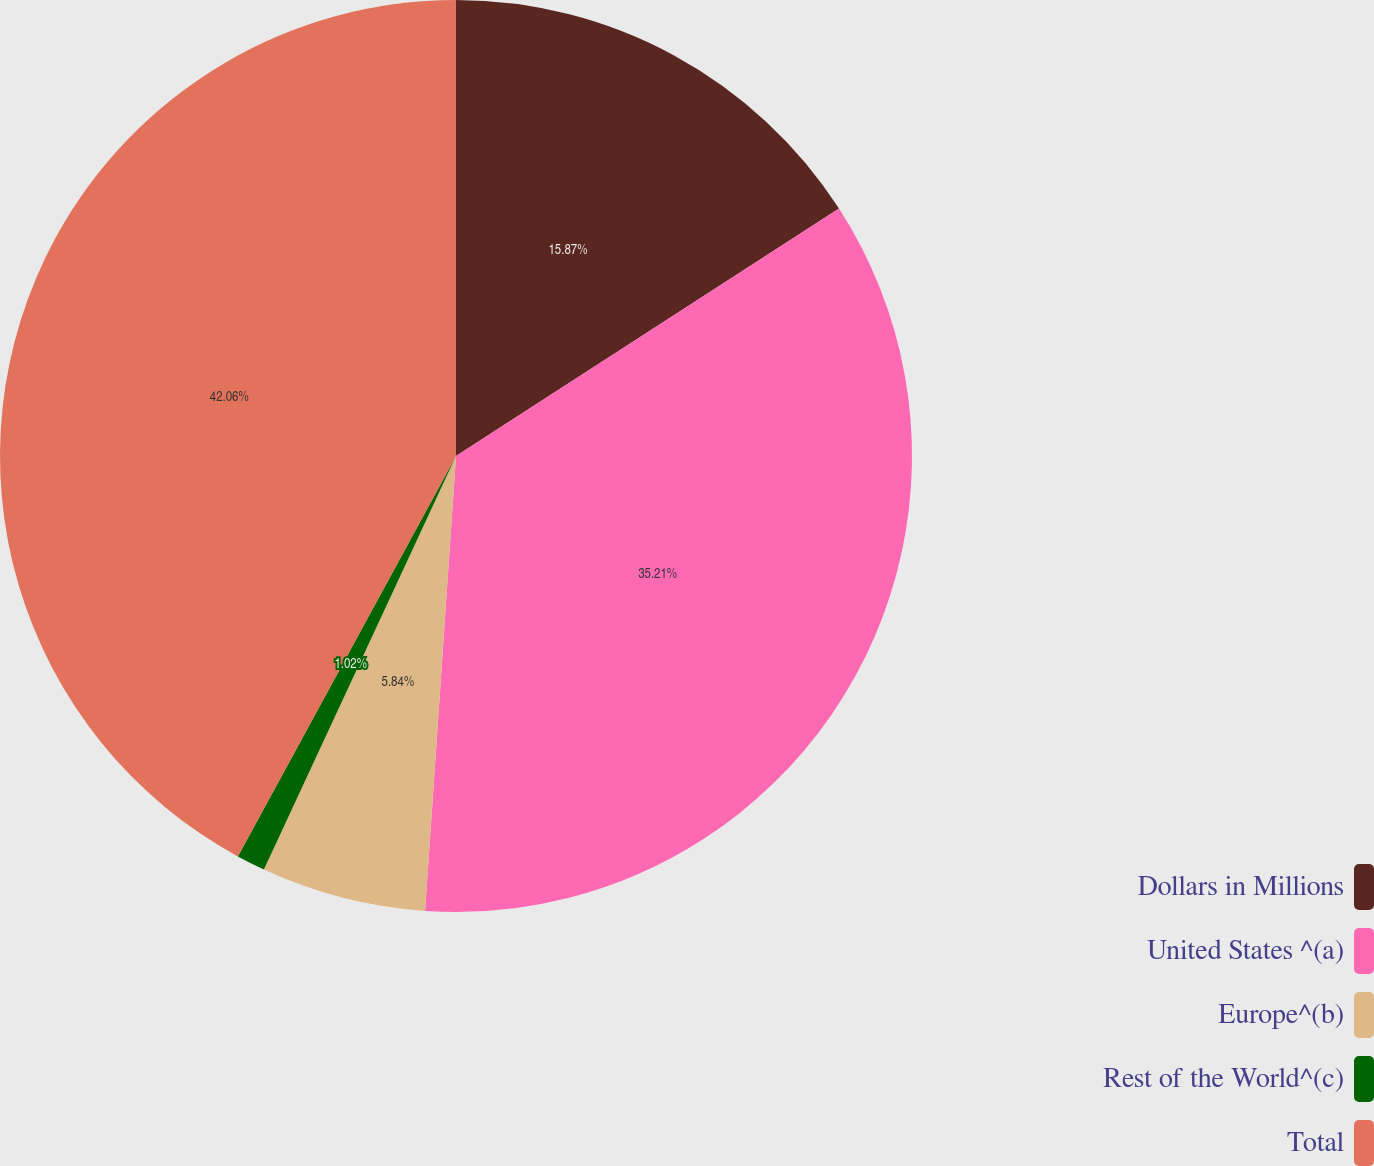Convert chart. <chart><loc_0><loc_0><loc_500><loc_500><pie_chart><fcel>Dollars in Millions<fcel>United States ^(a)<fcel>Europe^(b)<fcel>Rest of the World^(c)<fcel>Total<nl><fcel>15.87%<fcel>35.21%<fcel>5.84%<fcel>1.02%<fcel>42.06%<nl></chart> 